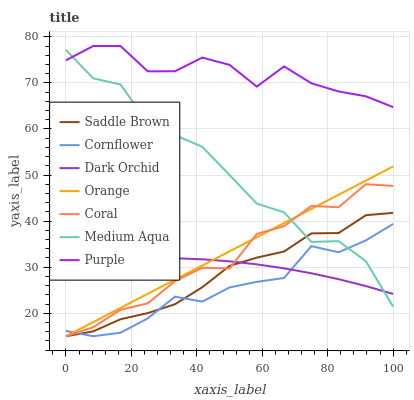Does Cornflower have the minimum area under the curve?
Answer yes or no. Yes. Does Purple have the maximum area under the curve?
Answer yes or no. Yes. Does Coral have the minimum area under the curve?
Answer yes or no. No. Does Coral have the maximum area under the curve?
Answer yes or no. No. Is Orange the smoothest?
Answer yes or no. Yes. Is Medium Aqua the roughest?
Answer yes or no. Yes. Is Purple the smoothest?
Answer yes or no. No. Is Purple the roughest?
Answer yes or no. No. Does Cornflower have the lowest value?
Answer yes or no. Yes. Does Purple have the lowest value?
Answer yes or no. No. Does Purple have the highest value?
Answer yes or no. Yes. Does Coral have the highest value?
Answer yes or no. No. Is Coral less than Purple?
Answer yes or no. Yes. Is Purple greater than Cornflower?
Answer yes or no. Yes. Does Orange intersect Dark Orchid?
Answer yes or no. Yes. Is Orange less than Dark Orchid?
Answer yes or no. No. Is Orange greater than Dark Orchid?
Answer yes or no. No. Does Coral intersect Purple?
Answer yes or no. No. 